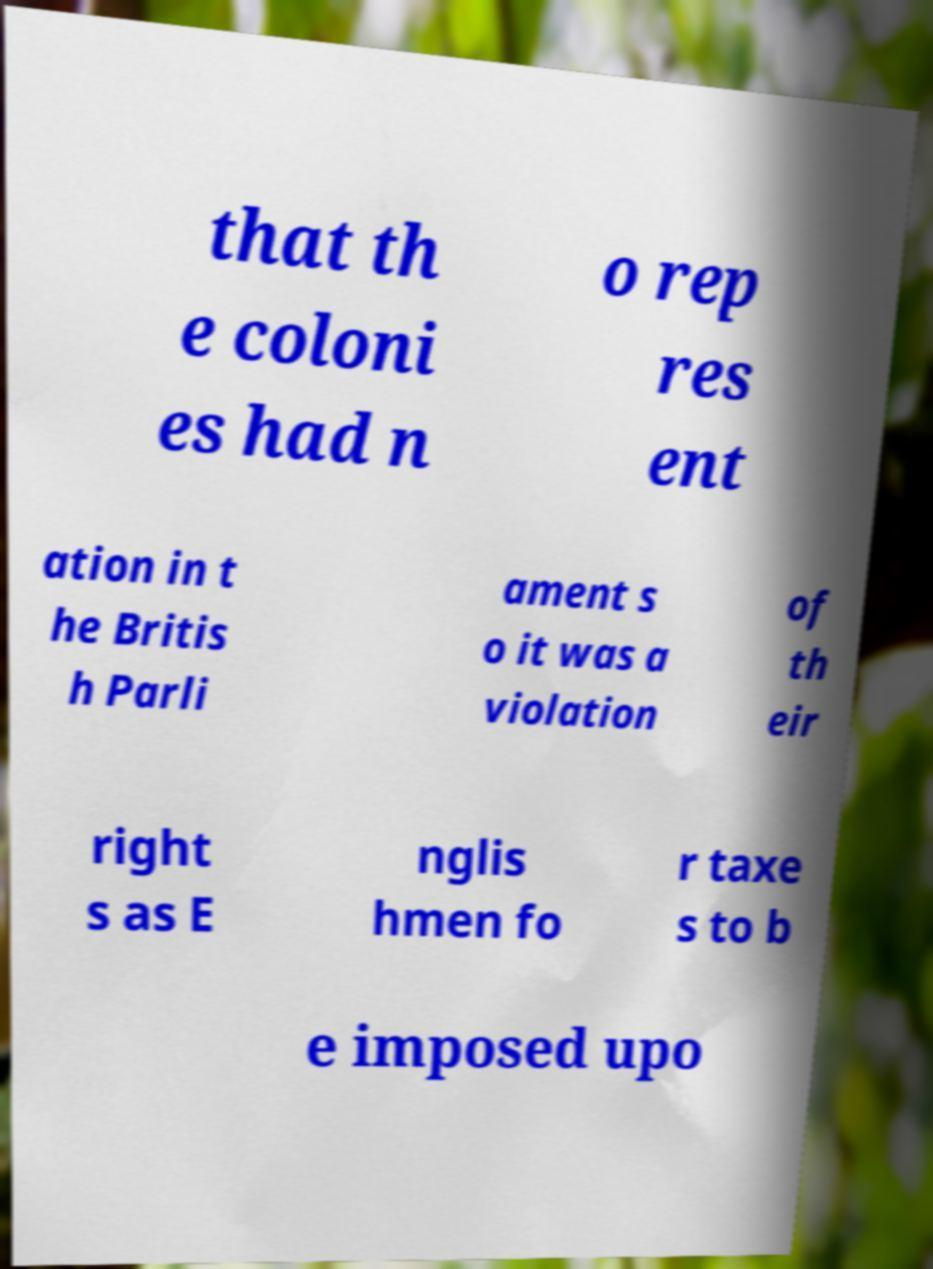Please read and relay the text visible in this image. What does it say? that th e coloni es had n o rep res ent ation in t he Britis h Parli ament s o it was a violation of th eir right s as E nglis hmen fo r taxe s to b e imposed upo 